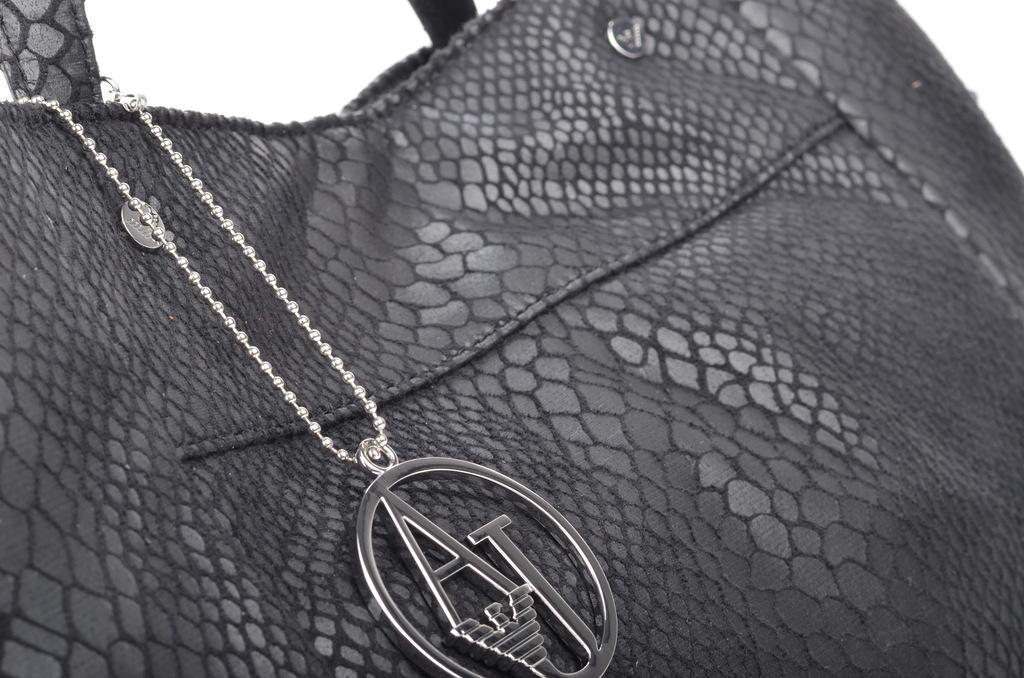What is the color of the bag in the image? The bag in the image is black. How is the bag connected to something else in the image? The bag is attached to a chain. What type of pot can be seen in the image? There is no pot present in the image; it only features a black color bag attached to a chain. How does the wax interact with the bag in the image? There is no wax present in the image, so it cannot interact with the bag. 